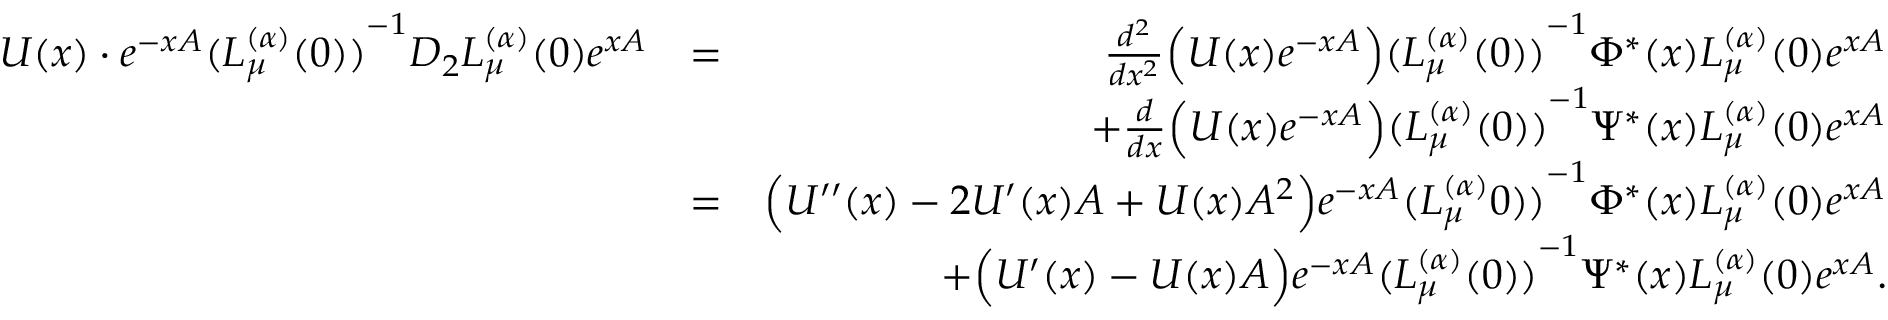<formula> <loc_0><loc_0><loc_500><loc_500>\begin{array} { r l r } { U ( x ) \cdot e ^ { - x A } { ( L _ { \mu } ^ { ( \alpha ) } ( 0 ) ) } ^ { - 1 } D _ { 2 } L _ { \mu } ^ { ( \alpha ) } ( 0 ) e ^ { x A } } & { = } & { \frac { d ^ { 2 } } { d x ^ { 2 } } \left ( U ( x ) e ^ { - x A } \right ) { ( L _ { \mu } ^ { ( \alpha ) } ( 0 ) ) } ^ { - 1 } \Phi ^ { \ast } ( x ) L _ { \mu } ^ { ( \alpha ) } ( 0 ) e ^ { x A } } \\ & { + \frac { d } { d x } \left ( U ( x ) e ^ { - x A } \right ) { ( L _ { \mu } ^ { ( \alpha ) } ( 0 ) ) } ^ { - 1 } \Psi ^ { \ast } ( x ) L _ { \mu } ^ { ( \alpha ) } ( 0 ) e ^ { x A } } \\ & { = } & { \left ( U ^ { \prime \prime } ( x ) - 2 U ^ { \prime } ( x ) A + U ( x ) A ^ { 2 } \right ) e ^ { - x A } { ( L _ { \mu } ^ { ( \alpha ) } 0 ) ) } ^ { - 1 } \Phi ^ { \ast } ( x ) L _ { \mu } ^ { ( \alpha ) } ( 0 ) e ^ { x A } } \\ & { + \left ( U ^ { \prime } ( x ) - U ( x ) A \right ) e ^ { - x A } { ( L _ { \mu } ^ { ( \alpha ) } ( 0 ) ) } ^ { - 1 } \Psi ^ { \ast } ( x ) L _ { \mu } ^ { ( \alpha ) } ( 0 ) e ^ { x A } . } \end{array}</formula> 